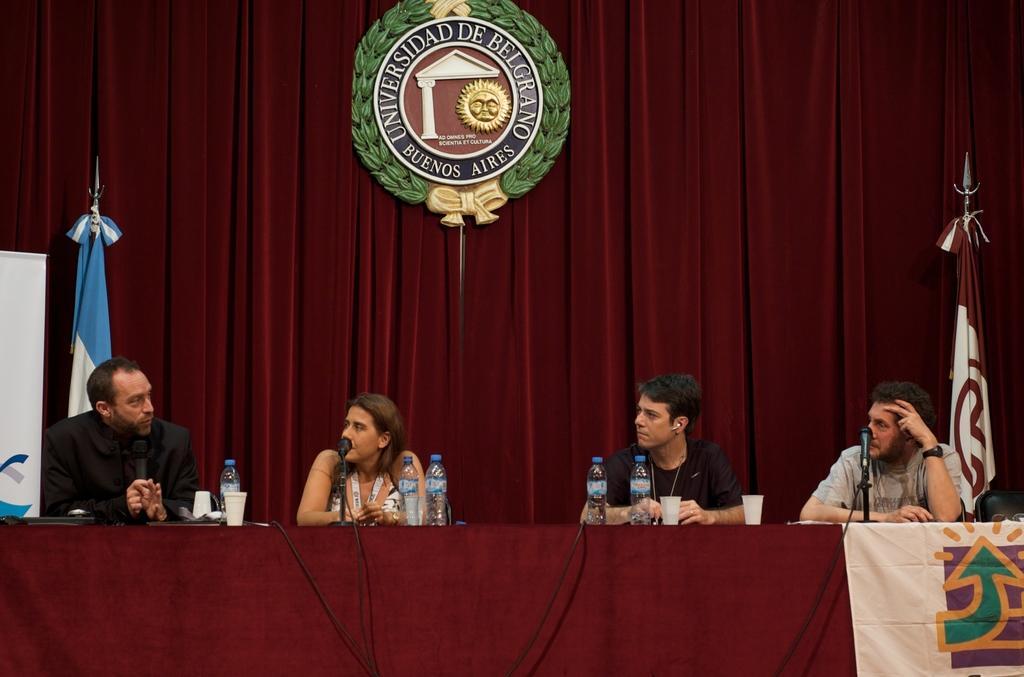Please provide a concise description of this image. In this image I can see the group of people with different color dresses. In-front of these people I can see the bottles,cups and few objects on the table. In the background I can see banner, flags and the badge attached to the maroon color curtains. 